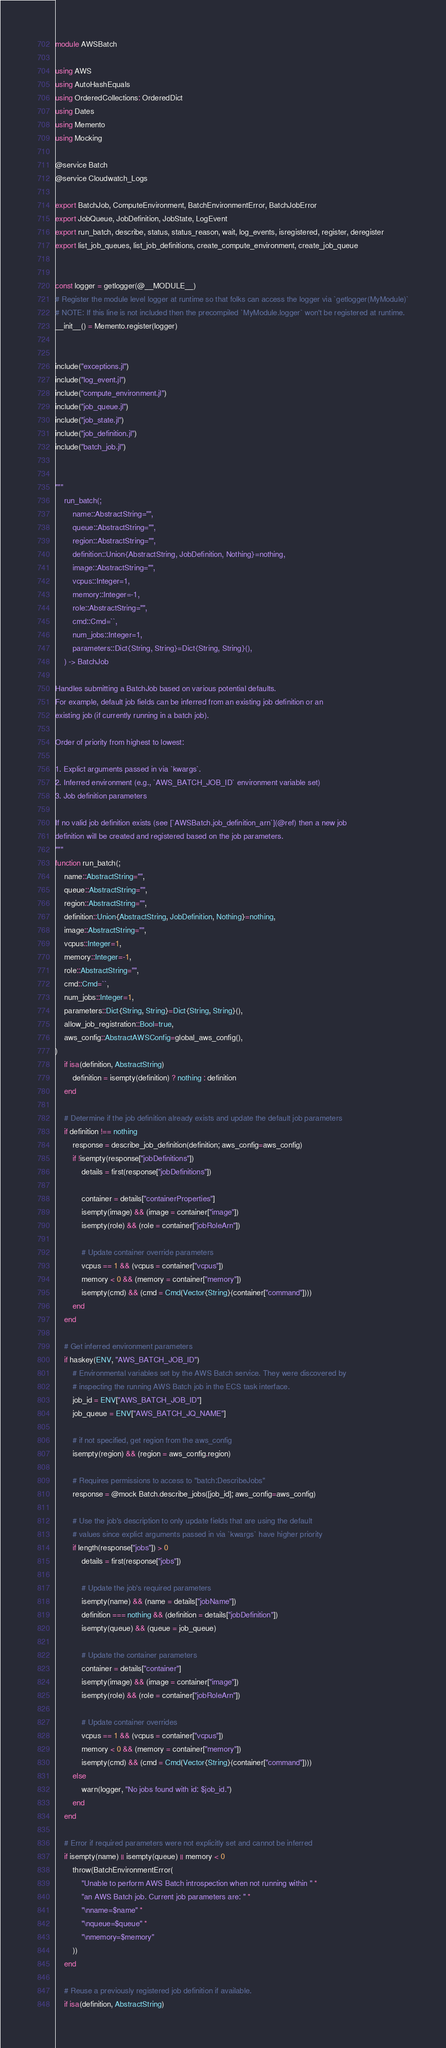Convert code to text. <code><loc_0><loc_0><loc_500><loc_500><_Julia_>module AWSBatch

using AWS
using AutoHashEquals
using OrderedCollections: OrderedDict
using Dates
using Memento
using Mocking

@service Batch
@service Cloudwatch_Logs

export BatchJob, ComputeEnvironment, BatchEnvironmentError, BatchJobError
export JobQueue, JobDefinition, JobState, LogEvent
export run_batch, describe, status, status_reason, wait, log_events, isregistered, register, deregister
export list_job_queues, list_job_definitions, create_compute_environment, create_job_queue


const logger = getlogger(@__MODULE__)
# Register the module level logger at runtime so that folks can access the logger via `getlogger(MyModule)`
# NOTE: If this line is not included then the precompiled `MyModule.logger` won't be registered at runtime.
__init__() = Memento.register(logger)


include("exceptions.jl")
include("log_event.jl")
include("compute_environment.jl")
include("job_queue.jl")
include("job_state.jl")
include("job_definition.jl")
include("batch_job.jl")


"""
    run_batch(;
        name::AbstractString="",
        queue::AbstractString="",
        region::AbstractString="",
        definition::Union{AbstractString, JobDefinition, Nothing}=nothing,
        image::AbstractString="",
        vcpus::Integer=1,
        memory::Integer=-1,
        role::AbstractString="",
        cmd::Cmd=``,
        num_jobs::Integer=1,
        parameters::Dict{String, String}=Dict{String, String}(),
    ) -> BatchJob

Handles submitting a BatchJob based on various potential defaults.
For example, default job fields can be inferred from an existing job definition or an
existing job (if currently running in a batch job).

Order of priority from highest to lowest:

1. Explict arguments passed in via `kwargs`.
2. Inferred environment (e.g., `AWS_BATCH_JOB_ID` environment variable set)
3. Job definition parameters

If no valid job definition exists (see [`AWSBatch.job_definition_arn`](@ref) then a new job
definition will be created and registered based on the job parameters.
"""
function run_batch(;
    name::AbstractString="",
    queue::AbstractString="",
    region::AbstractString="",
    definition::Union{AbstractString, JobDefinition, Nothing}=nothing,
    image::AbstractString="",
    vcpus::Integer=1,
    memory::Integer=-1,
    role::AbstractString="",
    cmd::Cmd=``,
    num_jobs::Integer=1,
    parameters::Dict{String, String}=Dict{String, String}(),
    allow_job_registration::Bool=true,
    aws_config::AbstractAWSConfig=global_aws_config(),
)
    if isa(definition, AbstractString)
        definition = isempty(definition) ? nothing : definition
    end

    # Determine if the job definition already exists and update the default job parameters
    if definition !== nothing
        response = describe_job_definition(definition; aws_config=aws_config)
        if !isempty(response["jobDefinitions"])
            details = first(response["jobDefinitions"])

            container = details["containerProperties"]
            isempty(image) && (image = container["image"])
            isempty(role) && (role = container["jobRoleArn"])

            # Update container override parameters
            vcpus == 1 && (vcpus = container["vcpus"])
            memory < 0 && (memory = container["memory"])
            isempty(cmd) && (cmd = Cmd(Vector{String}(container["command"])))
        end
    end

    # Get inferred environment parameters
    if haskey(ENV, "AWS_BATCH_JOB_ID")
        # Environmental variables set by the AWS Batch service. They were discovered by
        # inspecting the running AWS Batch job in the ECS task interface.
        job_id = ENV["AWS_BATCH_JOB_ID"]
        job_queue = ENV["AWS_BATCH_JQ_NAME"]

        # if not specified, get region from the aws_config
        isempty(region) && (region = aws_config.region)

        # Requires permissions to access to "batch:DescribeJobs"
        response = @mock Batch.describe_jobs([job_id]; aws_config=aws_config)

        # Use the job's description to only update fields that are using the default
        # values since explict arguments passed in via `kwargs` have higher priority
        if length(response["jobs"]) > 0
            details = first(response["jobs"])

            # Update the job's required parameters
            isempty(name) && (name = details["jobName"])
            definition === nothing && (definition = details["jobDefinition"])
            isempty(queue) && (queue = job_queue)

            # Update the container parameters
            container = details["container"]
            isempty(image) && (image = container["image"])
            isempty(role) && (role = container["jobRoleArn"])

            # Update container overrides
            vcpus == 1 && (vcpus = container["vcpus"])
            memory < 0 && (memory = container["memory"])
            isempty(cmd) && (cmd = Cmd(Vector{String}(container["command"])))
        else
            warn(logger, "No jobs found with id: $job_id.")
        end
    end

    # Error if required parameters were not explicitly set and cannot be inferred
    if isempty(name) || isempty(queue) || memory < 0
        throw(BatchEnvironmentError(
            "Unable to perform AWS Batch introspection when not running within " *
            "an AWS Batch job. Current job parameters are: " *
            "\nname=$name" *
            "\nqueue=$queue" *
            "\nmemory=$memory"
        ))
    end

    # Reuse a previously registered job definition if available.
    if isa(definition, AbstractString)</code> 